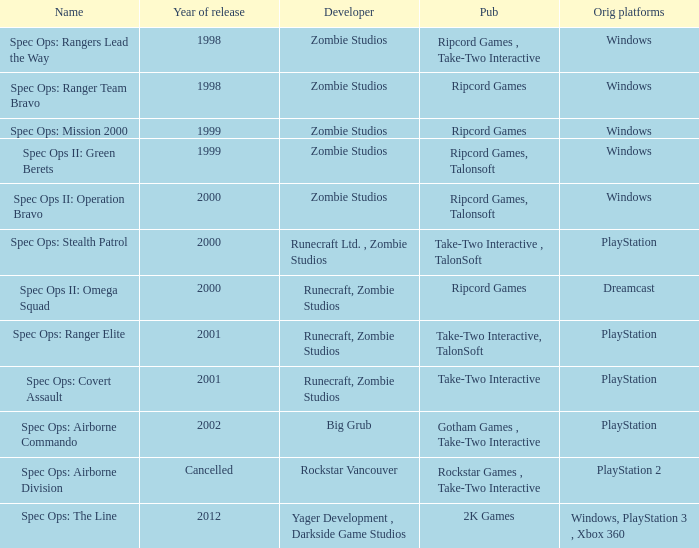Which publisher is responsible for releasing a game for the original dreamcast platform in 2000? Ripcord Games. 